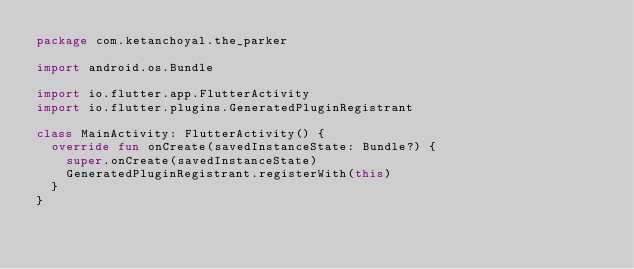<code> <loc_0><loc_0><loc_500><loc_500><_Kotlin_>package com.ketanchoyal.the_parker

import android.os.Bundle

import io.flutter.app.FlutterActivity
import io.flutter.plugins.GeneratedPluginRegistrant

class MainActivity: FlutterActivity() {
  override fun onCreate(savedInstanceState: Bundle?) {
    super.onCreate(savedInstanceState)
    GeneratedPluginRegistrant.registerWith(this)
  }
}
</code> 